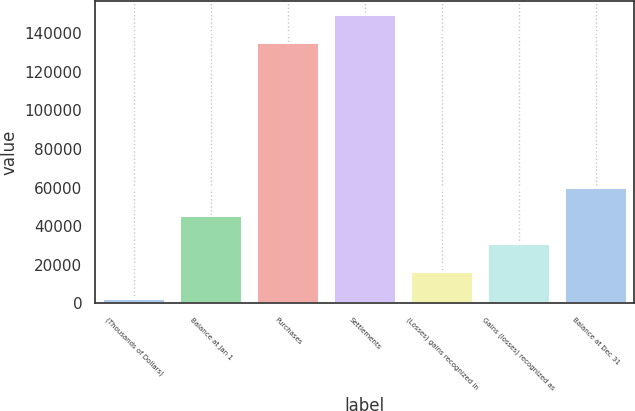Convert chart to OTSL. <chart><loc_0><loc_0><loc_500><loc_500><bar_chart><fcel>(Thousands of Dollars)<fcel>Balance at Jan 1<fcel>Purchases<fcel>Settlements<fcel>(Losses) gains recognized in<fcel>Gains (losses) recognized as<fcel>Balance at Dec 31<nl><fcel>2014<fcel>45202<fcel>135008<fcel>149404<fcel>16410<fcel>30806<fcel>59598<nl></chart> 